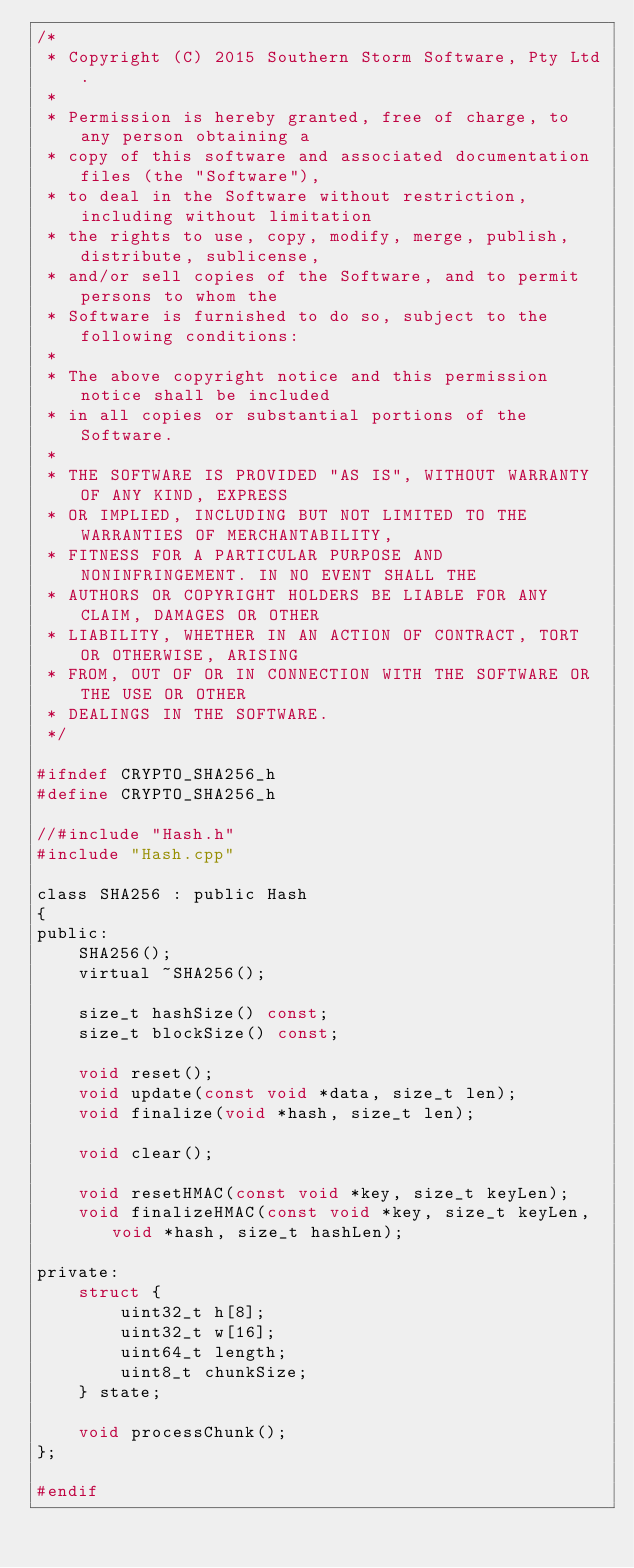Convert code to text. <code><loc_0><loc_0><loc_500><loc_500><_C_>/*
 * Copyright (C) 2015 Southern Storm Software, Pty Ltd.
 *
 * Permission is hereby granted, free of charge, to any person obtaining a
 * copy of this software and associated documentation files (the "Software"),
 * to deal in the Software without restriction, including without limitation
 * the rights to use, copy, modify, merge, publish, distribute, sublicense,
 * and/or sell copies of the Software, and to permit persons to whom the
 * Software is furnished to do so, subject to the following conditions:
 *
 * The above copyright notice and this permission notice shall be included
 * in all copies or substantial portions of the Software.
 *
 * THE SOFTWARE IS PROVIDED "AS IS", WITHOUT WARRANTY OF ANY KIND, EXPRESS
 * OR IMPLIED, INCLUDING BUT NOT LIMITED TO THE WARRANTIES OF MERCHANTABILITY,
 * FITNESS FOR A PARTICULAR PURPOSE AND NONINFRINGEMENT. IN NO EVENT SHALL THE
 * AUTHORS OR COPYRIGHT HOLDERS BE LIABLE FOR ANY CLAIM, DAMAGES OR OTHER
 * LIABILITY, WHETHER IN AN ACTION OF CONTRACT, TORT OR OTHERWISE, ARISING
 * FROM, OUT OF OR IN CONNECTION WITH THE SOFTWARE OR THE USE OR OTHER
 * DEALINGS IN THE SOFTWARE.
 */

#ifndef CRYPTO_SHA256_h
#define CRYPTO_SHA256_h

//#include "Hash.h"
#include "Hash.cpp"

class SHA256 : public Hash
{
public:
    SHA256();
    virtual ~SHA256();

    size_t hashSize() const;
    size_t blockSize() const;

    void reset();
    void update(const void *data, size_t len);
    void finalize(void *hash, size_t len);

    void clear();

    void resetHMAC(const void *key, size_t keyLen);
    void finalizeHMAC(const void *key, size_t keyLen, void *hash, size_t hashLen);

private:
    struct {
        uint32_t h[8];
        uint32_t w[16];
        uint64_t length;
        uint8_t chunkSize;
    } state;

    void processChunk();
};

#endif
</code> 